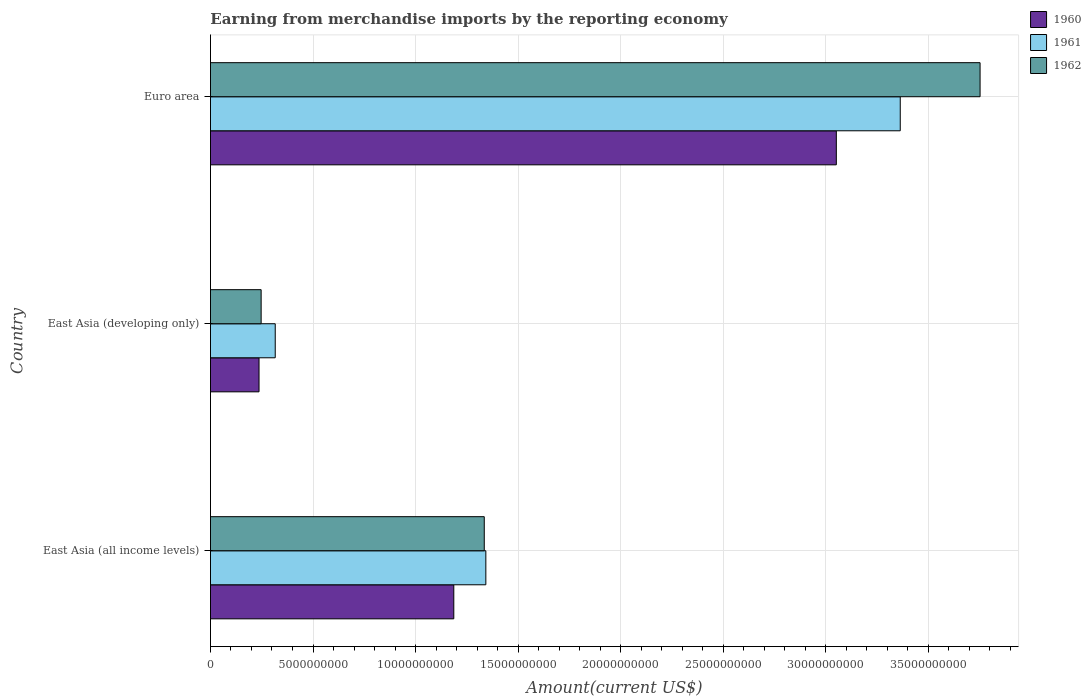How many groups of bars are there?
Ensure brevity in your answer.  3. Are the number of bars per tick equal to the number of legend labels?
Your response must be concise. Yes. Are the number of bars on each tick of the Y-axis equal?
Your response must be concise. Yes. How many bars are there on the 2nd tick from the top?
Keep it short and to the point. 3. What is the label of the 2nd group of bars from the top?
Make the answer very short. East Asia (developing only). In how many cases, is the number of bars for a given country not equal to the number of legend labels?
Your answer should be compact. 0. What is the amount earned from merchandise imports in 1962 in East Asia (all income levels)?
Provide a short and direct response. 1.34e+1. Across all countries, what is the maximum amount earned from merchandise imports in 1960?
Your answer should be very brief. 3.05e+1. Across all countries, what is the minimum amount earned from merchandise imports in 1962?
Make the answer very short. 2.47e+09. In which country was the amount earned from merchandise imports in 1962 maximum?
Give a very brief answer. Euro area. In which country was the amount earned from merchandise imports in 1961 minimum?
Provide a succinct answer. East Asia (developing only). What is the total amount earned from merchandise imports in 1961 in the graph?
Give a very brief answer. 5.02e+1. What is the difference between the amount earned from merchandise imports in 1961 in East Asia (all income levels) and that in Euro area?
Offer a terse response. -2.02e+1. What is the difference between the amount earned from merchandise imports in 1960 in Euro area and the amount earned from merchandise imports in 1961 in East Asia (all income levels)?
Your response must be concise. 1.71e+1. What is the average amount earned from merchandise imports in 1960 per country?
Keep it short and to the point. 1.49e+1. What is the difference between the amount earned from merchandise imports in 1962 and amount earned from merchandise imports in 1961 in East Asia (developing only)?
Keep it short and to the point. -6.88e+08. In how many countries, is the amount earned from merchandise imports in 1961 greater than 18000000000 US$?
Give a very brief answer. 1. What is the ratio of the amount earned from merchandise imports in 1962 in East Asia (developing only) to that in Euro area?
Make the answer very short. 0.07. Is the amount earned from merchandise imports in 1960 in East Asia (all income levels) less than that in Euro area?
Ensure brevity in your answer.  Yes. What is the difference between the highest and the second highest amount earned from merchandise imports in 1960?
Keep it short and to the point. 1.87e+1. What is the difference between the highest and the lowest amount earned from merchandise imports in 1960?
Your response must be concise. 2.82e+1. What does the 3rd bar from the bottom in East Asia (developing only) represents?
Offer a terse response. 1962. Are all the bars in the graph horizontal?
Your answer should be compact. Yes. How many countries are there in the graph?
Keep it short and to the point. 3. What is the difference between two consecutive major ticks on the X-axis?
Your answer should be very brief. 5.00e+09. Are the values on the major ticks of X-axis written in scientific E-notation?
Provide a succinct answer. No. Does the graph contain grids?
Provide a succinct answer. Yes. Where does the legend appear in the graph?
Offer a very short reply. Top right. How many legend labels are there?
Your answer should be compact. 3. What is the title of the graph?
Keep it short and to the point. Earning from merchandise imports by the reporting economy. Does "2007" appear as one of the legend labels in the graph?
Make the answer very short. No. What is the label or title of the X-axis?
Offer a terse response. Amount(current US$). What is the Amount(current US$) of 1960 in East Asia (all income levels)?
Give a very brief answer. 1.19e+1. What is the Amount(current US$) in 1961 in East Asia (all income levels)?
Ensure brevity in your answer.  1.34e+1. What is the Amount(current US$) of 1962 in East Asia (all income levels)?
Give a very brief answer. 1.34e+1. What is the Amount(current US$) in 1960 in East Asia (developing only)?
Make the answer very short. 2.37e+09. What is the Amount(current US$) of 1961 in East Asia (developing only)?
Your response must be concise. 3.16e+09. What is the Amount(current US$) of 1962 in East Asia (developing only)?
Offer a very short reply. 2.47e+09. What is the Amount(current US$) of 1960 in Euro area?
Offer a terse response. 3.05e+1. What is the Amount(current US$) in 1961 in Euro area?
Offer a terse response. 3.36e+1. What is the Amount(current US$) in 1962 in Euro area?
Offer a terse response. 3.75e+1. Across all countries, what is the maximum Amount(current US$) in 1960?
Keep it short and to the point. 3.05e+1. Across all countries, what is the maximum Amount(current US$) in 1961?
Ensure brevity in your answer.  3.36e+1. Across all countries, what is the maximum Amount(current US$) of 1962?
Your response must be concise. 3.75e+1. Across all countries, what is the minimum Amount(current US$) in 1960?
Make the answer very short. 2.37e+09. Across all countries, what is the minimum Amount(current US$) in 1961?
Your answer should be compact. 3.16e+09. Across all countries, what is the minimum Amount(current US$) in 1962?
Offer a terse response. 2.47e+09. What is the total Amount(current US$) of 1960 in the graph?
Offer a terse response. 4.48e+1. What is the total Amount(current US$) in 1961 in the graph?
Give a very brief answer. 5.02e+1. What is the total Amount(current US$) of 1962 in the graph?
Your response must be concise. 5.34e+1. What is the difference between the Amount(current US$) of 1960 in East Asia (all income levels) and that in East Asia (developing only)?
Make the answer very short. 9.50e+09. What is the difference between the Amount(current US$) of 1961 in East Asia (all income levels) and that in East Asia (developing only)?
Make the answer very short. 1.03e+1. What is the difference between the Amount(current US$) of 1962 in East Asia (all income levels) and that in East Asia (developing only)?
Make the answer very short. 1.09e+1. What is the difference between the Amount(current US$) in 1960 in East Asia (all income levels) and that in Euro area?
Your response must be concise. -1.87e+1. What is the difference between the Amount(current US$) of 1961 in East Asia (all income levels) and that in Euro area?
Provide a short and direct response. -2.02e+1. What is the difference between the Amount(current US$) in 1962 in East Asia (all income levels) and that in Euro area?
Offer a terse response. -2.42e+1. What is the difference between the Amount(current US$) of 1960 in East Asia (developing only) and that in Euro area?
Keep it short and to the point. -2.82e+1. What is the difference between the Amount(current US$) of 1961 in East Asia (developing only) and that in Euro area?
Offer a terse response. -3.05e+1. What is the difference between the Amount(current US$) in 1962 in East Asia (developing only) and that in Euro area?
Keep it short and to the point. -3.51e+1. What is the difference between the Amount(current US$) of 1960 in East Asia (all income levels) and the Amount(current US$) of 1961 in East Asia (developing only)?
Ensure brevity in your answer.  8.71e+09. What is the difference between the Amount(current US$) of 1960 in East Asia (all income levels) and the Amount(current US$) of 1962 in East Asia (developing only)?
Provide a short and direct response. 9.40e+09. What is the difference between the Amount(current US$) in 1961 in East Asia (all income levels) and the Amount(current US$) in 1962 in East Asia (developing only)?
Your answer should be very brief. 1.10e+1. What is the difference between the Amount(current US$) in 1960 in East Asia (all income levels) and the Amount(current US$) in 1961 in Euro area?
Provide a short and direct response. -2.18e+1. What is the difference between the Amount(current US$) in 1960 in East Asia (all income levels) and the Amount(current US$) in 1962 in Euro area?
Your answer should be compact. -2.57e+1. What is the difference between the Amount(current US$) of 1961 in East Asia (all income levels) and the Amount(current US$) of 1962 in Euro area?
Your answer should be very brief. -2.41e+1. What is the difference between the Amount(current US$) of 1960 in East Asia (developing only) and the Amount(current US$) of 1961 in Euro area?
Keep it short and to the point. -3.13e+1. What is the difference between the Amount(current US$) of 1960 in East Asia (developing only) and the Amount(current US$) of 1962 in Euro area?
Ensure brevity in your answer.  -3.52e+1. What is the difference between the Amount(current US$) of 1961 in East Asia (developing only) and the Amount(current US$) of 1962 in Euro area?
Your answer should be very brief. -3.44e+1. What is the average Amount(current US$) of 1960 per country?
Offer a terse response. 1.49e+1. What is the average Amount(current US$) in 1961 per country?
Offer a terse response. 1.67e+1. What is the average Amount(current US$) of 1962 per country?
Your answer should be very brief. 1.78e+1. What is the difference between the Amount(current US$) of 1960 and Amount(current US$) of 1961 in East Asia (all income levels)?
Provide a short and direct response. -1.56e+09. What is the difference between the Amount(current US$) in 1960 and Amount(current US$) in 1962 in East Asia (all income levels)?
Offer a terse response. -1.49e+09. What is the difference between the Amount(current US$) of 1961 and Amount(current US$) of 1962 in East Asia (all income levels)?
Your answer should be compact. 7.72e+07. What is the difference between the Amount(current US$) of 1960 and Amount(current US$) of 1961 in East Asia (developing only)?
Provide a short and direct response. -7.90e+08. What is the difference between the Amount(current US$) in 1960 and Amount(current US$) in 1962 in East Asia (developing only)?
Give a very brief answer. -1.03e+08. What is the difference between the Amount(current US$) in 1961 and Amount(current US$) in 1962 in East Asia (developing only)?
Your answer should be compact. 6.88e+08. What is the difference between the Amount(current US$) in 1960 and Amount(current US$) in 1961 in Euro area?
Provide a succinct answer. -3.12e+09. What is the difference between the Amount(current US$) in 1960 and Amount(current US$) in 1962 in Euro area?
Your answer should be very brief. -7.01e+09. What is the difference between the Amount(current US$) of 1961 and Amount(current US$) of 1962 in Euro area?
Provide a succinct answer. -3.89e+09. What is the ratio of the Amount(current US$) of 1960 in East Asia (all income levels) to that in East Asia (developing only)?
Offer a terse response. 5.01. What is the ratio of the Amount(current US$) of 1961 in East Asia (all income levels) to that in East Asia (developing only)?
Provide a succinct answer. 4.25. What is the ratio of the Amount(current US$) of 1962 in East Asia (all income levels) to that in East Asia (developing only)?
Make the answer very short. 5.4. What is the ratio of the Amount(current US$) in 1960 in East Asia (all income levels) to that in Euro area?
Ensure brevity in your answer.  0.39. What is the ratio of the Amount(current US$) of 1961 in East Asia (all income levels) to that in Euro area?
Ensure brevity in your answer.  0.4. What is the ratio of the Amount(current US$) in 1962 in East Asia (all income levels) to that in Euro area?
Make the answer very short. 0.36. What is the ratio of the Amount(current US$) in 1960 in East Asia (developing only) to that in Euro area?
Make the answer very short. 0.08. What is the ratio of the Amount(current US$) in 1961 in East Asia (developing only) to that in Euro area?
Your response must be concise. 0.09. What is the ratio of the Amount(current US$) of 1962 in East Asia (developing only) to that in Euro area?
Give a very brief answer. 0.07. What is the difference between the highest and the second highest Amount(current US$) of 1960?
Provide a succinct answer. 1.87e+1. What is the difference between the highest and the second highest Amount(current US$) in 1961?
Offer a terse response. 2.02e+1. What is the difference between the highest and the second highest Amount(current US$) in 1962?
Offer a very short reply. 2.42e+1. What is the difference between the highest and the lowest Amount(current US$) of 1960?
Offer a very short reply. 2.82e+1. What is the difference between the highest and the lowest Amount(current US$) in 1961?
Ensure brevity in your answer.  3.05e+1. What is the difference between the highest and the lowest Amount(current US$) in 1962?
Ensure brevity in your answer.  3.51e+1. 